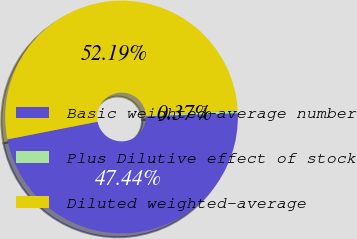Convert chart to OTSL. <chart><loc_0><loc_0><loc_500><loc_500><pie_chart><fcel>Basic weighted-average number<fcel>Plus Dilutive effect of stock<fcel>Diluted weighted-average<nl><fcel>47.44%<fcel>0.37%<fcel>52.18%<nl></chart> 